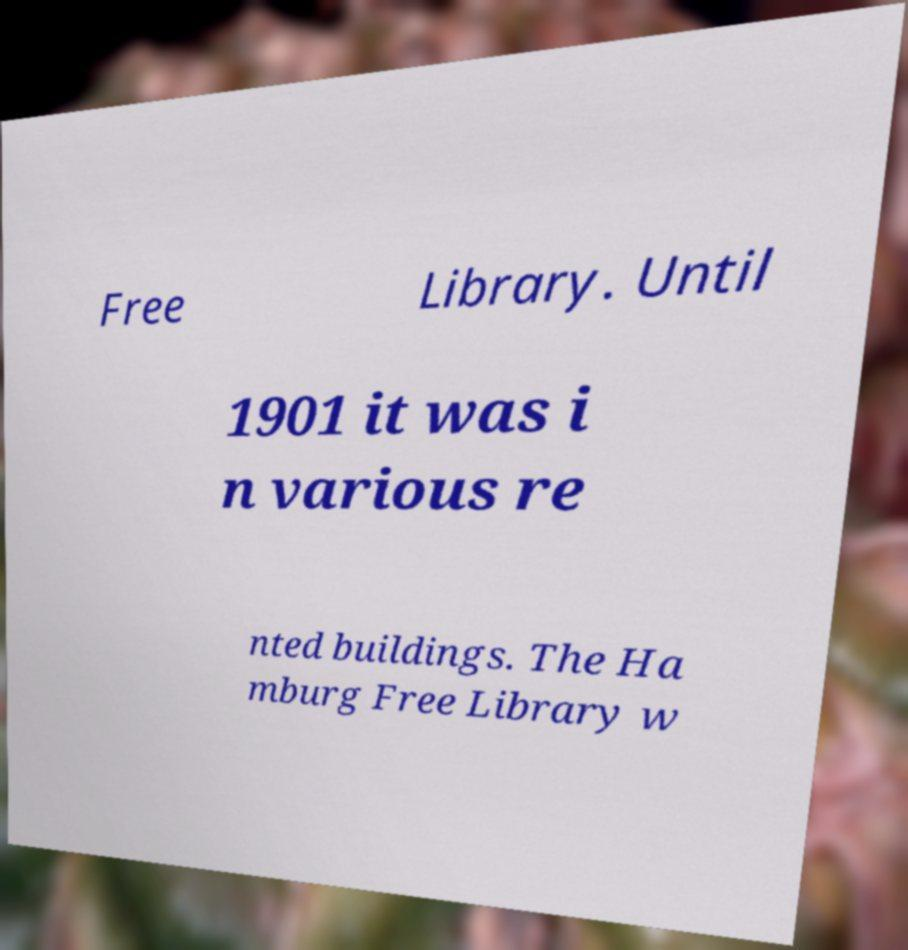I need the written content from this picture converted into text. Can you do that? Free Library. Until 1901 it was i n various re nted buildings. The Ha mburg Free Library w 